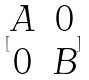<formula> <loc_0><loc_0><loc_500><loc_500>[ \begin{matrix} A & 0 \\ 0 & B \end{matrix} ]</formula> 